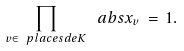Convert formula to latex. <formula><loc_0><loc_0><loc_500><loc_500>\prod _ { v \in \ p l a c e s d e { K } } \ a b s { x } _ { v } \, = \, 1 .</formula> 